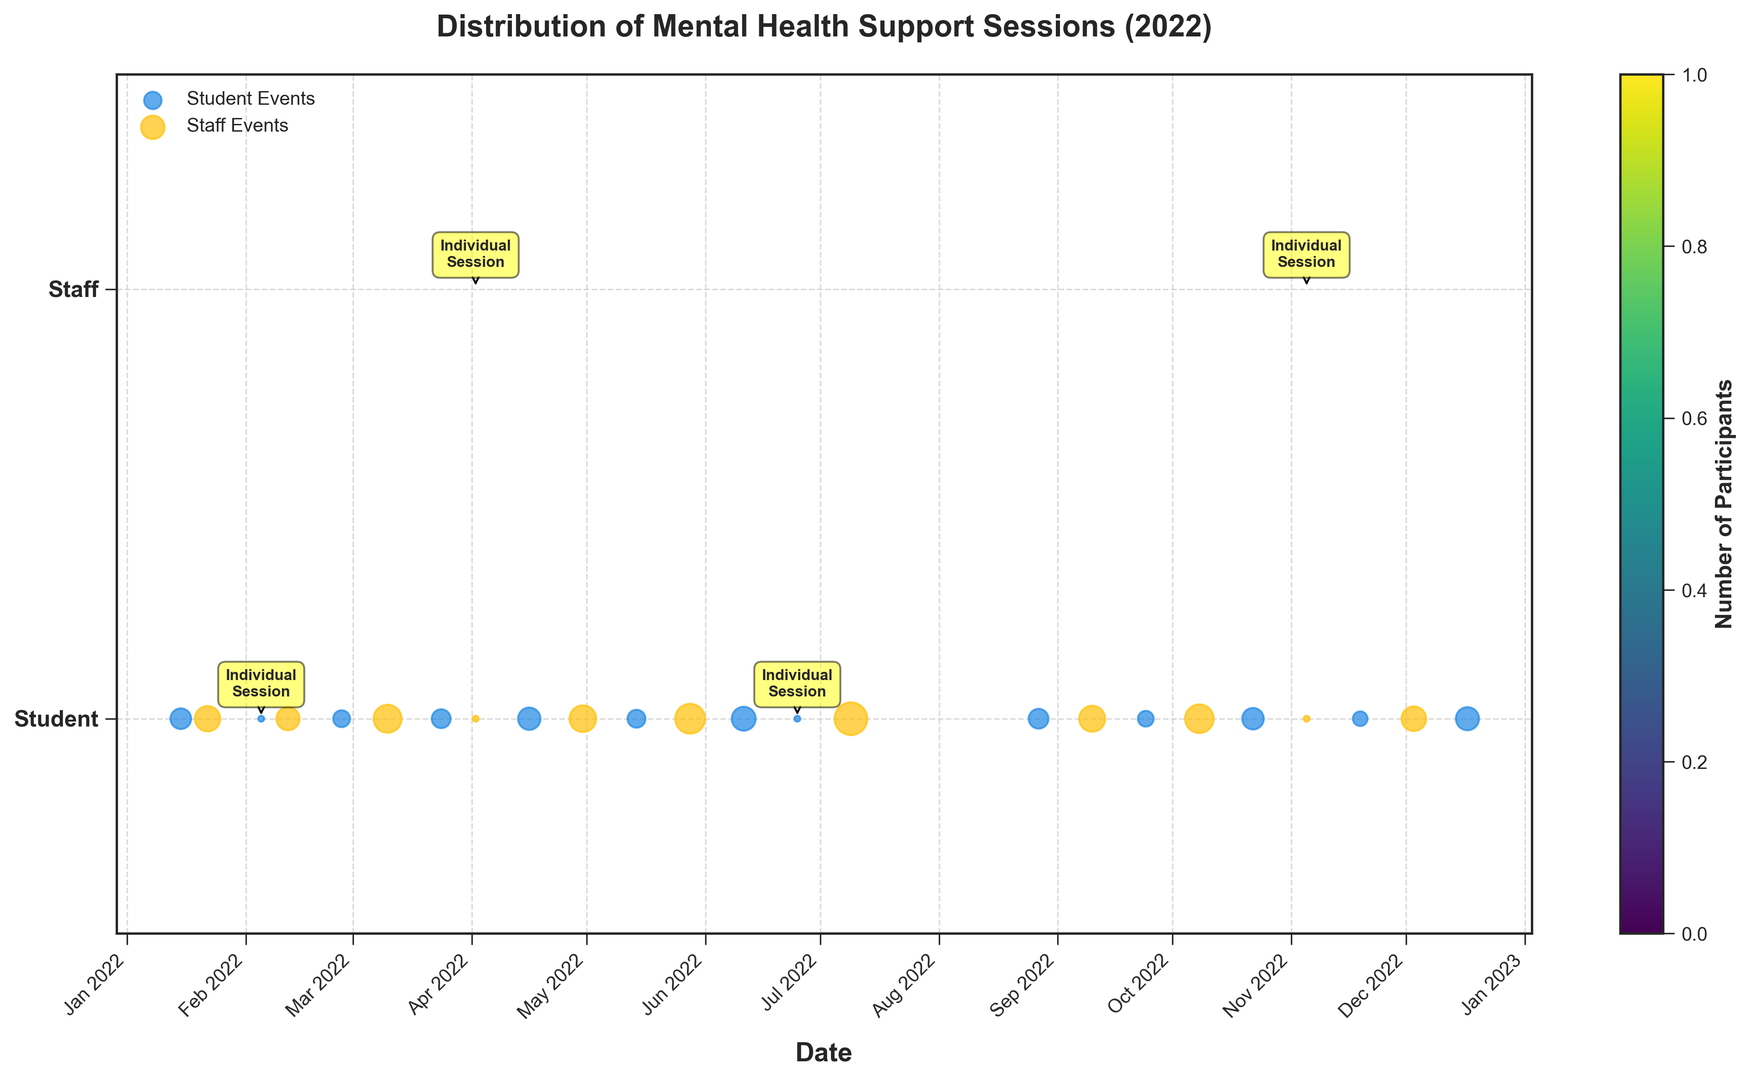Which month had the highest number of participants in mental health support sessions? Look for the month that has the highest aggregation of bubble sizes across both student and staff events to determine which had the maximum participants. From visual inspection, August has the largest cumulative bubble sizes (28 from student events and 19 from staff events).
Answer: August What is the total number of participants in staff events over the year? Sum up the sizes of the bubbles on the 'Staff' row which corresponds to the staff events. These sizes represent the number of participants in each event: 18 + 15 + 22 + 1 + 20 + 25 + 30 + 28 + 19 + 23 + 1 + 17 = 219.
Answer: 219 Compare the number of participants in individual counseling sessions for students versus staff. Which is higher? Note that the individual counseling sessions are annotated on the plot and have participant count of 1 each time. Count the occurrences and sum up the participants for each group: Individual Student Counseling = 1 (Feb) + 1 (Jun) = 2; Individual Staff Counseling = 1 (Apr) + 1 (Nov) = 2. Both have a total of 2 participants.
Answer: Equal What is the average number of participants per event for student events? To find the average, sum up the participants of all student events and divide by the number of student events. Participants: 12 + 1 + 8 + 10 + 14 + 9 + 16 + 1 + 11 + 7 + 13 + 6 + 15; Number of events: 13. Average = (Total Participants) / (Number of Events) = 123 / 13 ≈ 9.46.
Answer: Approximately 9.46 Which event had the maximum number of participants and how many? Identify the single largest bubble in terms of size. Visually, the largest bubble appears in the 'Summer Staff Wellness Retreat' event which has a participant size of 30.
Answer: Summer Staff Wellness Retreat, 30 Are there more student events or staff/teacher events over the year? Count the number of events in each category from the y-axis: Student Events = 13; Staff/Teacher Events = 12.
Answer: Student Events Do student events tend to have participants more or less than staff events? Compare the average bubble size of student events against that of staff events. While individual viewing might note this, a calculated comparison will be more accurate: for instance, Student Events Avg = 9.46; Staff Events include participants: 18, 15, 22, 1, 20, 25, 30, 28, 19, 23, 1, 17 which on average is 219/12 ≈ 18.25, indicating Staff events generally have higher participation.
Answer: Less What month had the highest diversity of event types (student and staff events)? Look for the month where both student and staff events are present and count those bubbles. In April, there are both staff events (Individual Staff Counseling) and student events (Student Bullying Prevention).
Answer: April Which quarter of the year saw the highest number of student events? Breakdown the year into four quarters and count the number of student events in each. Q1 (Jan-Mar): 2 (Jan-Student Group Therapy) + 1 (Mar-Student Depression Workshop); Q2 (Apr-Jun): 2 (Apr-Student Bullying) + 1 (Jun-Student Exam Stress); Q3 (Jul-Sep): 0; Q4 (Oct-Dec): 4 (Oct to Dec). Quarter 4 with 4 events has the highest number.
Answer: Q4 